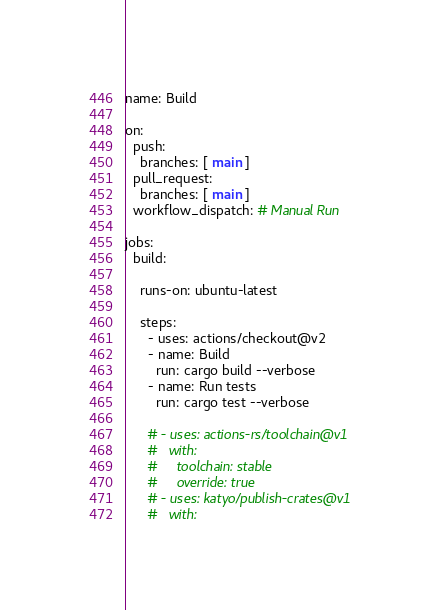Convert code to text. <code><loc_0><loc_0><loc_500><loc_500><_YAML_>name: Build

on:
  push:
    branches: [ main ]
  pull_request:
    branches: [ main ]
  workflow_dispatch: # Manual Run

jobs:
  build:

    runs-on: ubuntu-latest

    steps:
      - uses: actions/checkout@v2
      - name: Build
        run: cargo build --verbose
      - name: Run tests
        run: cargo test --verbose

      # - uses: actions-rs/toolchain@v1
      #   with:
      #     toolchain: stable
      #     override: true
      # - uses: katyo/publish-crates@v1
      #   with:</code> 